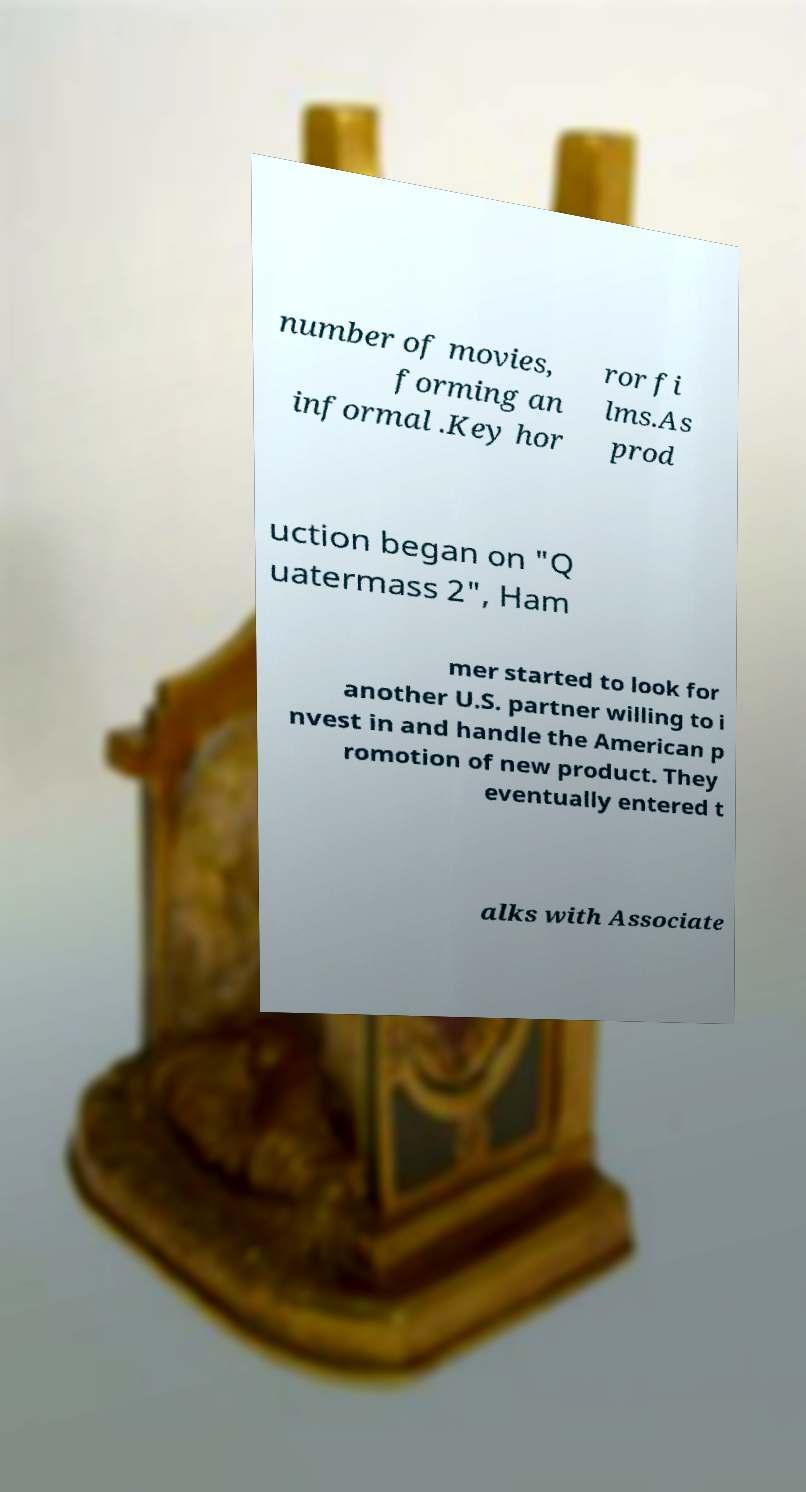Could you assist in decoding the text presented in this image and type it out clearly? number of movies, forming an informal .Key hor ror fi lms.As prod uction began on "Q uatermass 2", Ham mer started to look for another U.S. partner willing to i nvest in and handle the American p romotion of new product. They eventually entered t alks with Associate 